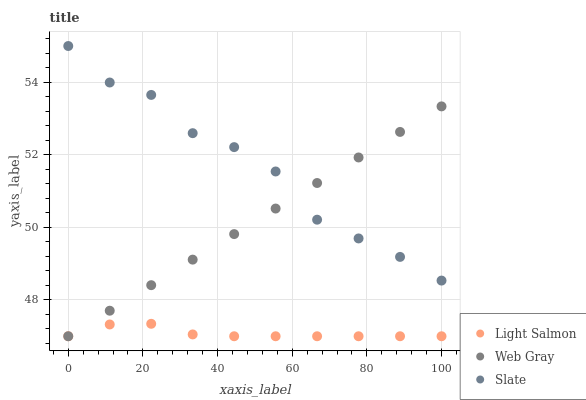Does Light Salmon have the minimum area under the curve?
Answer yes or no. Yes. Does Slate have the maximum area under the curve?
Answer yes or no. Yes. Does Web Gray have the minimum area under the curve?
Answer yes or no. No. Does Web Gray have the maximum area under the curve?
Answer yes or no. No. Is Web Gray the smoothest?
Answer yes or no. Yes. Is Slate the roughest?
Answer yes or no. Yes. Is Slate the smoothest?
Answer yes or no. No. Is Web Gray the roughest?
Answer yes or no. No. Does Light Salmon have the lowest value?
Answer yes or no. Yes. Does Slate have the lowest value?
Answer yes or no. No. Does Slate have the highest value?
Answer yes or no. Yes. Does Web Gray have the highest value?
Answer yes or no. No. Is Light Salmon less than Slate?
Answer yes or no. Yes. Is Slate greater than Light Salmon?
Answer yes or no. Yes. Does Light Salmon intersect Web Gray?
Answer yes or no. Yes. Is Light Salmon less than Web Gray?
Answer yes or no. No. Is Light Salmon greater than Web Gray?
Answer yes or no. No. Does Light Salmon intersect Slate?
Answer yes or no. No. 